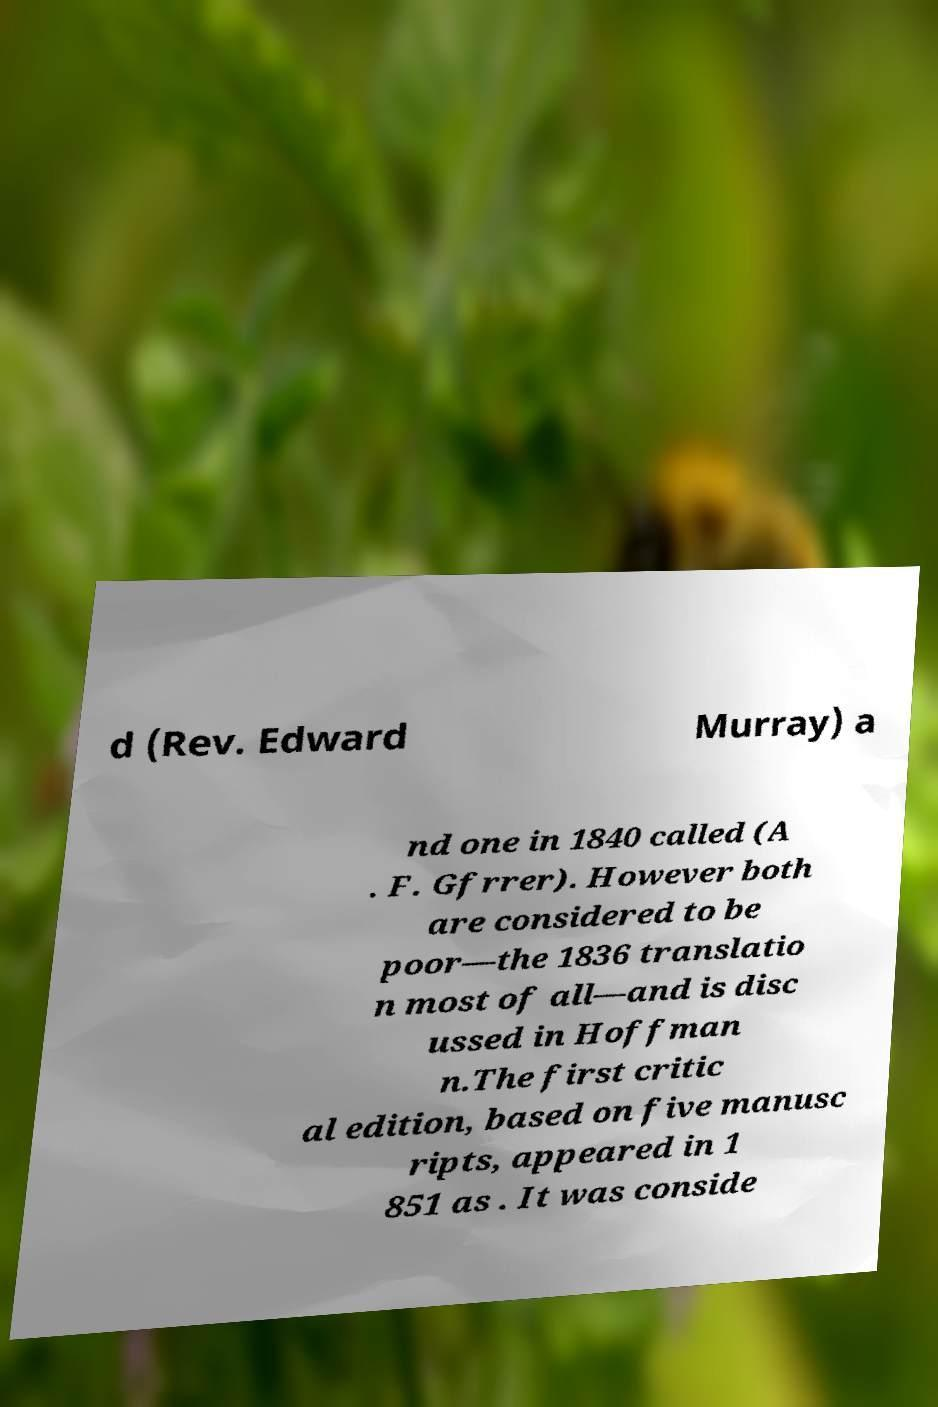Can you read and provide the text displayed in the image?This photo seems to have some interesting text. Can you extract and type it out for me? d (Rev. Edward Murray) a nd one in 1840 called (A . F. Gfrrer). However both are considered to be poor—the 1836 translatio n most of all—and is disc ussed in Hoffman n.The first critic al edition, based on five manusc ripts, appeared in 1 851 as . It was conside 